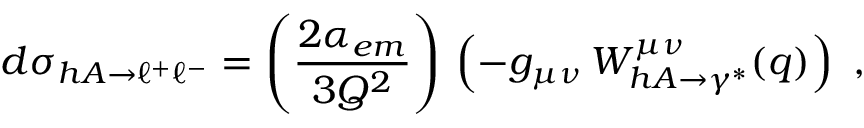<formula> <loc_0><loc_0><loc_500><loc_500>d \sigma _ { h A \rightarrow \ell ^ { + } \ell ^ { - } } = \left ( \frac { 2 \alpha _ { e m } } { 3 Q ^ { 2 } } \right ) \, \left ( - g _ { \mu \nu } \, W _ { h A \rightarrow \gamma ^ { * } } ^ { \mu \nu } ( q ) \right ) \ ,</formula> 